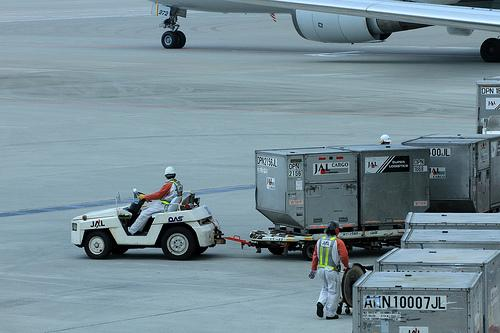What type of vehicle is being described by the image annotations? An airplane with black wheels and an engine is described in the image. In reference to the image, how many men are mentioned as wearing safety equipment (hard hat or safety vest)? Two men are mentioned wearing safety equipment in the image. Enumerate the various objects found around the airplane. Engine, black wheels, part of a wing, grey cement, luggage, and cargo containers. Explain the main activity occurring in the image involving the workers and airplane. The workers are unloading cargo, pulling containers, and towing luggage from the airplane. Describe the state of the road in the image as well as any markings on it. The road is gray with a blue line on it. Discuss the role of the workers in the image, including their attire. Workers are wearing safety vests, hard hats, and headphones for protection. They are managing cargo, pulling metal containers, and assisting with luggage. Identify the colors mentioned in relation to different objects within the image. White (truck, pants, cart, hard hat), silver (containers, tank, canisters), blue (line on road), gray (road, cement), black (wheels, shoes), red (hook). Describe the condition and contents of the silver containers. The silver containers are filled with cargo and have stickers and the number n100074 written on the side. Provide a brief description of the location this image was taken. The image was taken at an airport, where the airplane is parked on grey cement, and there is a blue line on the ground. 